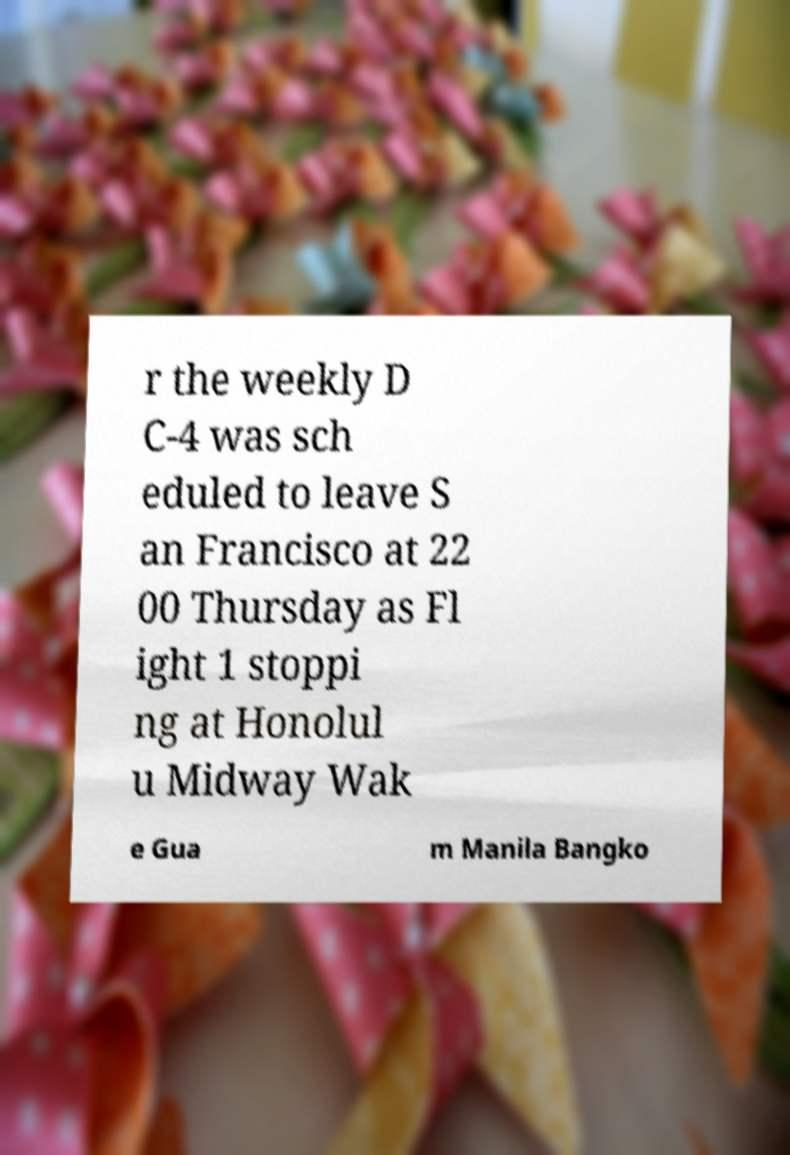There's text embedded in this image that I need extracted. Can you transcribe it verbatim? r the weekly D C-4 was sch eduled to leave S an Francisco at 22 00 Thursday as Fl ight 1 stoppi ng at Honolul u Midway Wak e Gua m Manila Bangko 